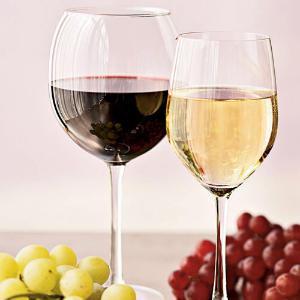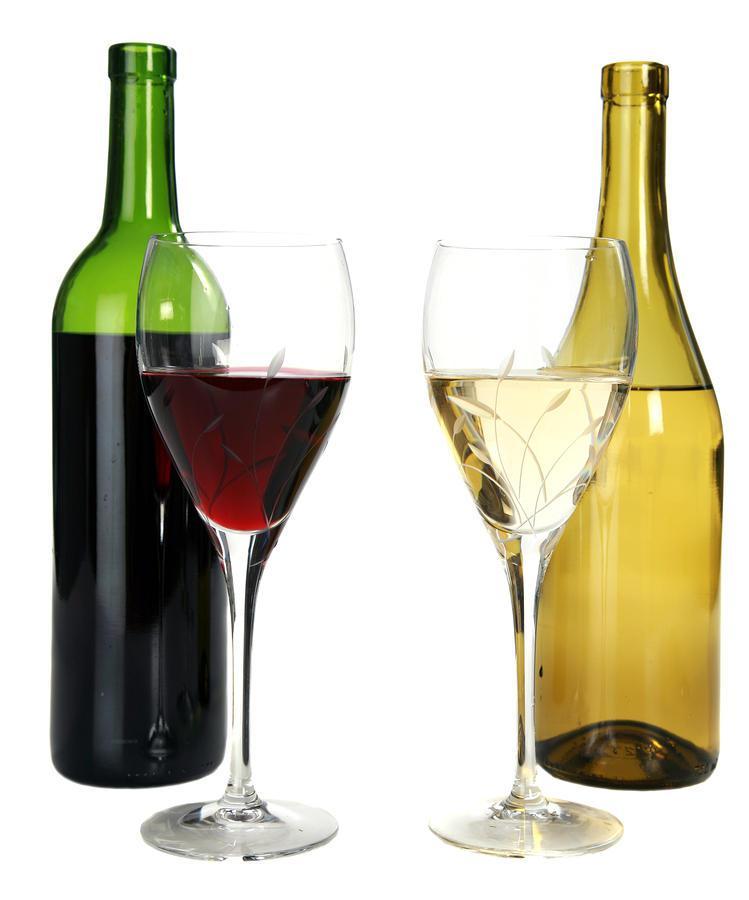The first image is the image on the left, the second image is the image on the right. Analyze the images presented: Is the assertion "In one image, two glasses of wine are sitting before at least one bottle." valid? Answer yes or no. Yes. 